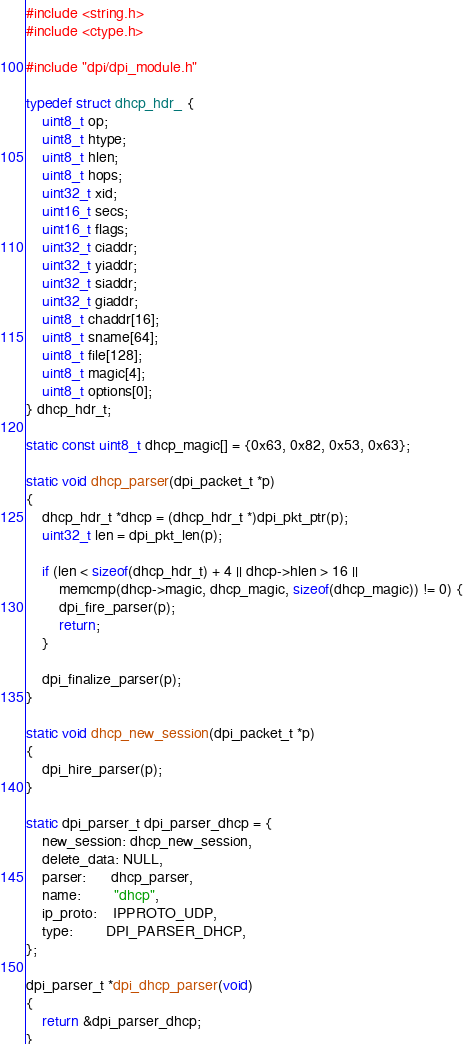<code> <loc_0><loc_0><loc_500><loc_500><_C_>#include <string.h>
#include <ctype.h>

#include "dpi/dpi_module.h"

typedef struct dhcp_hdr_ {
    uint8_t op;
    uint8_t htype;
    uint8_t hlen;
    uint8_t hops;
    uint32_t xid;
    uint16_t secs;
    uint16_t flags;
    uint32_t ciaddr;
    uint32_t yiaddr;
    uint32_t siaddr;
    uint32_t giaddr;
    uint8_t chaddr[16];
    uint8_t sname[64];
    uint8_t file[128];
    uint8_t magic[4];
    uint8_t options[0];
} dhcp_hdr_t;

static const uint8_t dhcp_magic[] = {0x63, 0x82, 0x53, 0x63};

static void dhcp_parser(dpi_packet_t *p)
{
    dhcp_hdr_t *dhcp = (dhcp_hdr_t *)dpi_pkt_ptr(p);
    uint32_t len = dpi_pkt_len(p);

    if (len < sizeof(dhcp_hdr_t) + 4 || dhcp->hlen > 16 ||
        memcmp(dhcp->magic, dhcp_magic, sizeof(dhcp_magic)) != 0) {
        dpi_fire_parser(p);
        return;
    }

    dpi_finalize_parser(p);
}

static void dhcp_new_session(dpi_packet_t *p)
{
    dpi_hire_parser(p);
}

static dpi_parser_t dpi_parser_dhcp = {
    new_session: dhcp_new_session,
    delete_data: NULL,
    parser:      dhcp_parser,
    name:        "dhcp",
    ip_proto:    IPPROTO_UDP,
    type:        DPI_PARSER_DHCP,
};

dpi_parser_t *dpi_dhcp_parser(void)
{
    return &dpi_parser_dhcp;
}
</code> 